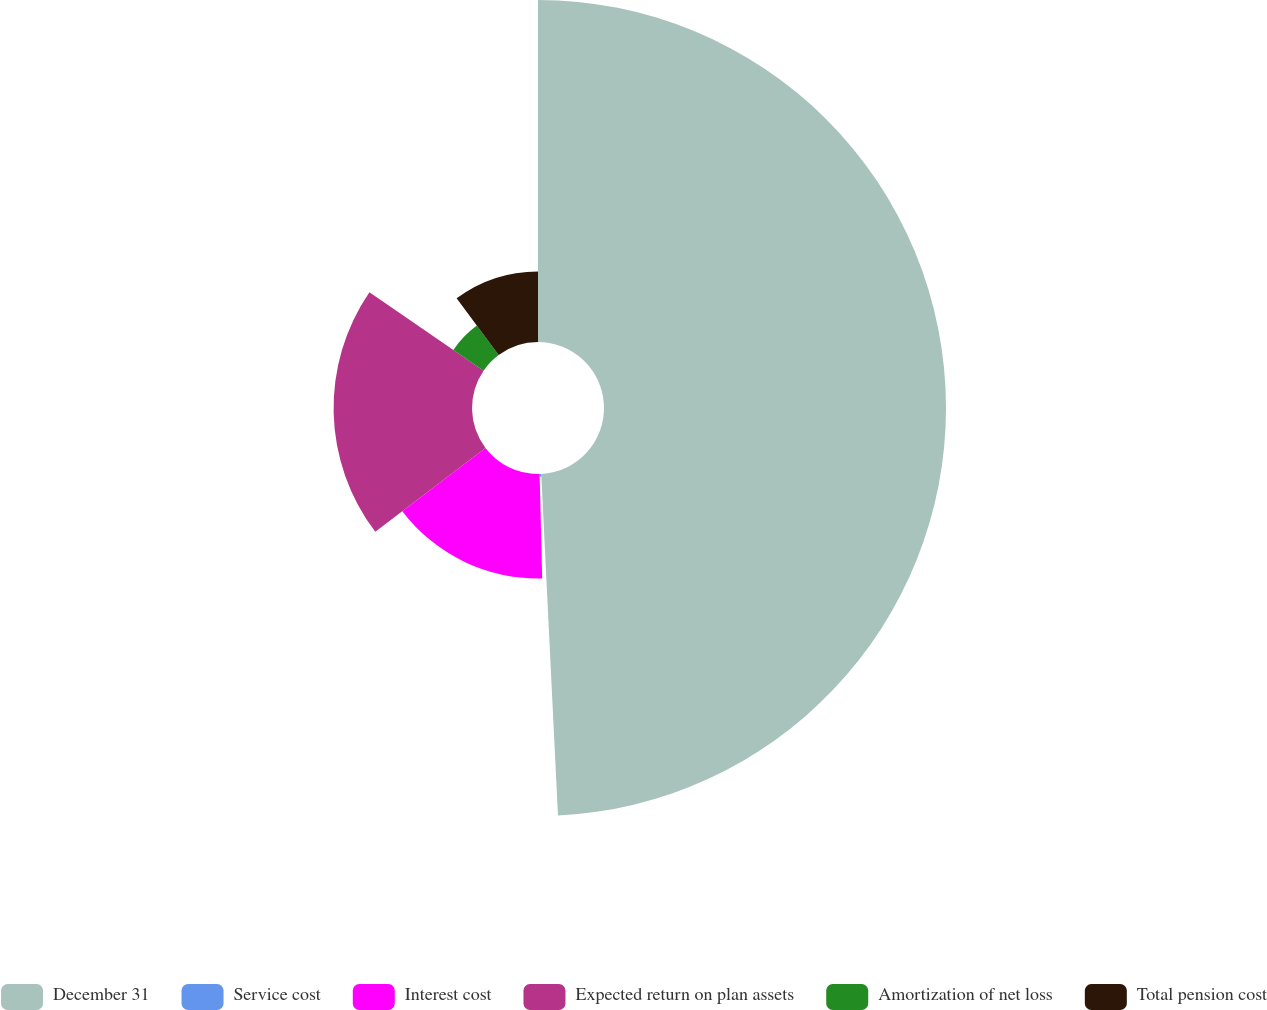Convert chart to OTSL. <chart><loc_0><loc_0><loc_500><loc_500><pie_chart><fcel>December 31<fcel>Service cost<fcel>Interest cost<fcel>Expected return on plan assets<fcel>Amortization of net loss<fcel>Total pension cost<nl><fcel>49.22%<fcel>0.39%<fcel>15.04%<fcel>19.92%<fcel>5.27%<fcel>10.16%<nl></chart> 